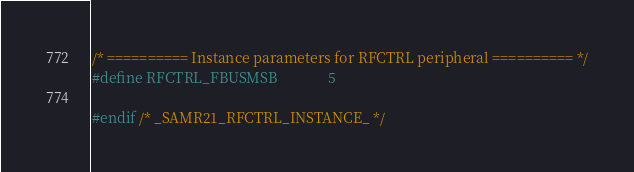Convert code to text. <code><loc_0><loc_0><loc_500><loc_500><_C_>
/* ========== Instance parameters for RFCTRL peripheral ========== */
#define RFCTRL_FBUSMSB              5

#endif /* _SAMR21_RFCTRL_INSTANCE_ */
</code> 